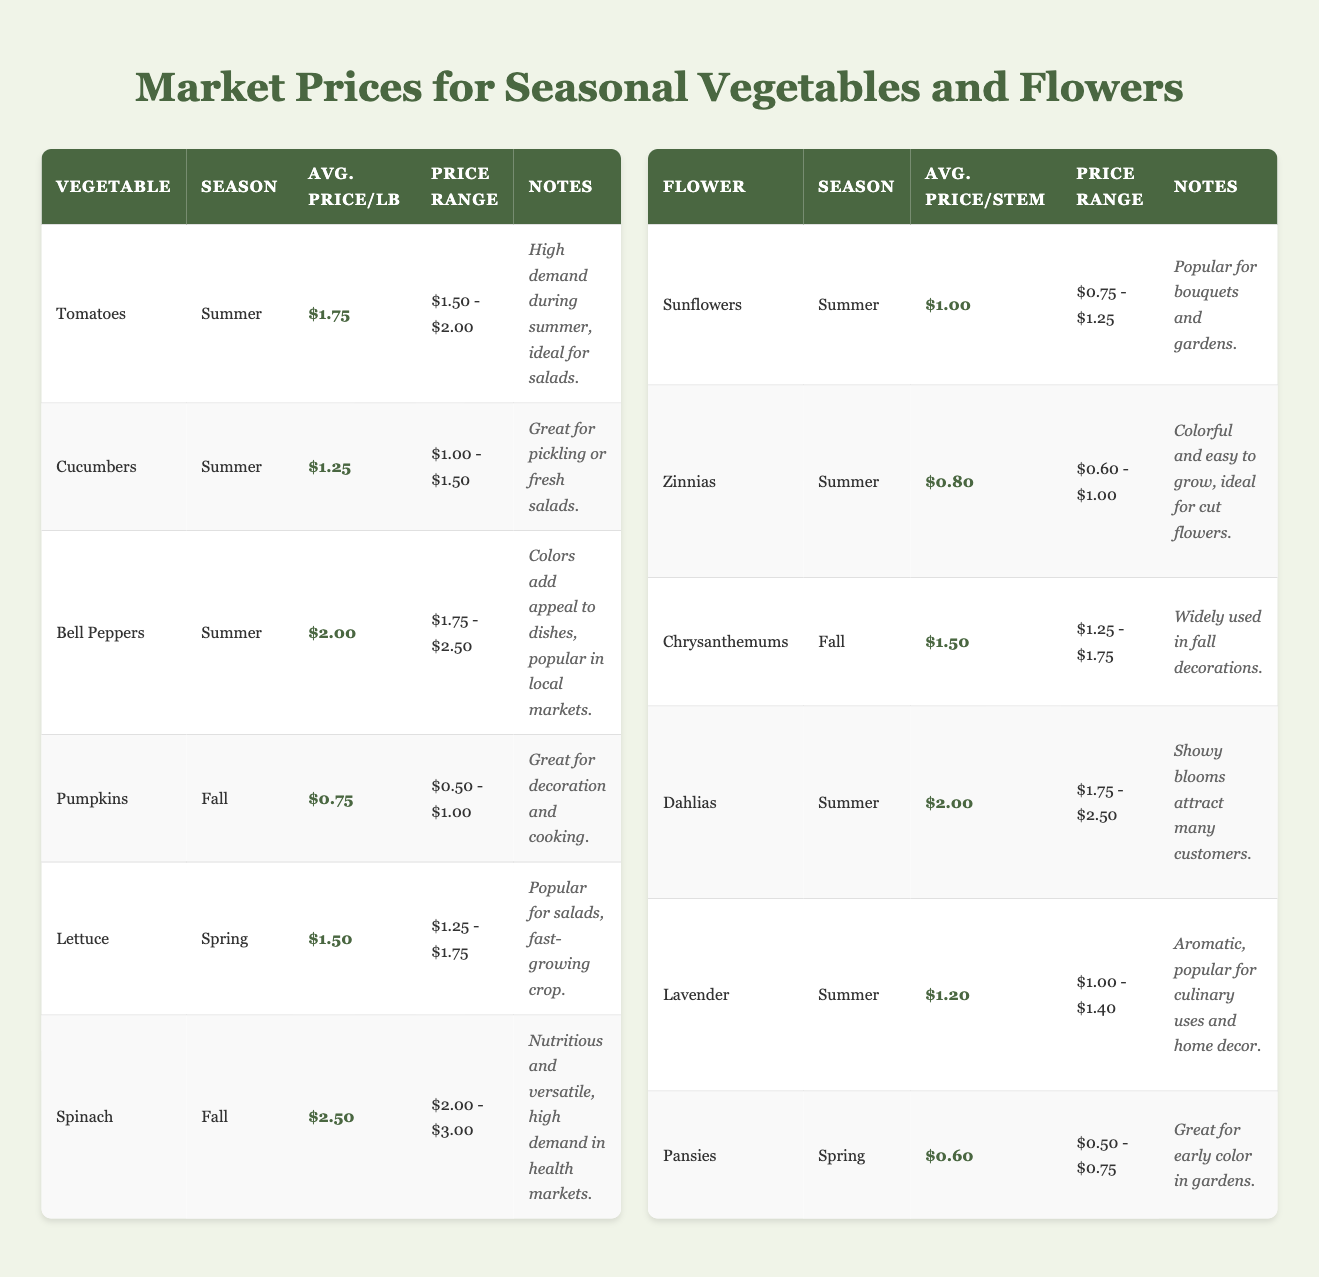What is the average price per pound for Bell Peppers? The average price for Bell Peppers is listed in the table under "Avg. Price/lb" as $2.00.
Answer: $2.00 Which vegetable has the highest average price per pound? By comparing the "Avg. Price/lb" for all vegetables, Spinach has the highest price at $2.50.
Answer: Spinach Are Zinnias available in the Fall season? The table indicates that Zinnias are only available in the Summer season, so the answer is no.
Answer: No What is the market price range for Pumpkins? The market price range for Pumpkins is stated in the table as $0.50 - $1.00.
Answer: $0.50 - $1.00 How many flower varieties are listed for Summer season? The table identifies four flowers available in the Summer: Sunflowers, Zinnias, Dahlias, and Lavender.
Answer: 4 What is the average price per stem for flowers in Spring? The only flower in the Spring season is Pansies, whose average price per stem is $0.60. Since there's only one, the average is $0.60.
Answer: $0.60 Which vegetable has the lowest average price per pound? The average prices indicate that Pumpkins, at $0.75, have the lowest average price when compared to the other vegetables.
Answer: Pumpkins What is the total average price per stem for Summer flowers? The average prices for Summer flowers are: Sunflowers ($1.00), Zinnias ($0.80), Dahlias ($2.00), and Lavender ($1.20). The total is $1.00 + $0.80 + $2.00 + $1.20 = $5.00. The average price is $5.00/4 = $1.25.
Answer: $1.25 Are there any vegetables listed for the Spring season? The table shows that Lettuce is the only vegetable available in the Spring season, so the answer is yes.
Answer: Yes Which flower in the Fall has the highest average price per stem? The Fall flowers include only Chrysanthemums, which average $1.50 per stem. This is the only option, making it the highest for that season.
Answer: Chrysanthemums 